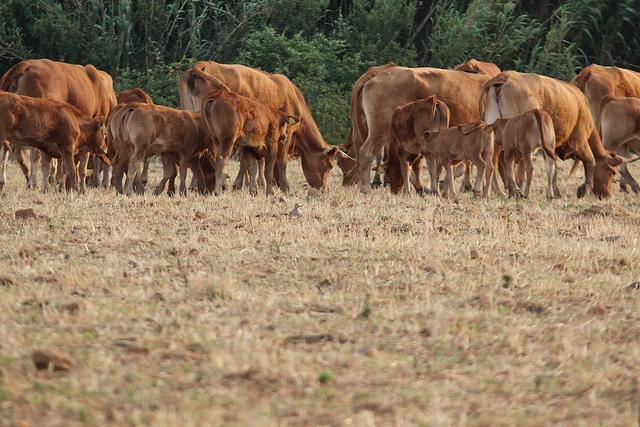How many cows are visible?
Give a very brief answer. 10. How many men are in the picture?
Give a very brief answer. 0. 